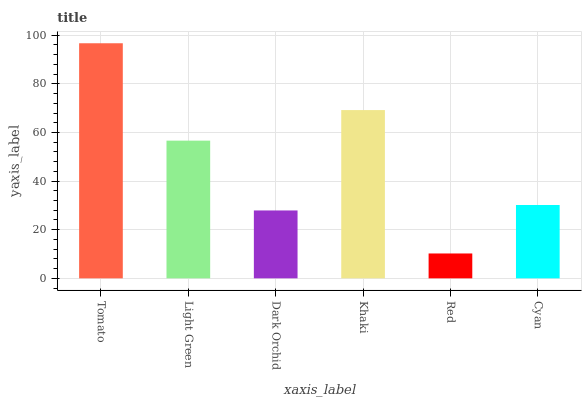Is Red the minimum?
Answer yes or no. Yes. Is Tomato the maximum?
Answer yes or no. Yes. Is Light Green the minimum?
Answer yes or no. No. Is Light Green the maximum?
Answer yes or no. No. Is Tomato greater than Light Green?
Answer yes or no. Yes. Is Light Green less than Tomato?
Answer yes or no. Yes. Is Light Green greater than Tomato?
Answer yes or no. No. Is Tomato less than Light Green?
Answer yes or no. No. Is Light Green the high median?
Answer yes or no. Yes. Is Cyan the low median?
Answer yes or no. Yes. Is Khaki the high median?
Answer yes or no. No. Is Khaki the low median?
Answer yes or no. No. 